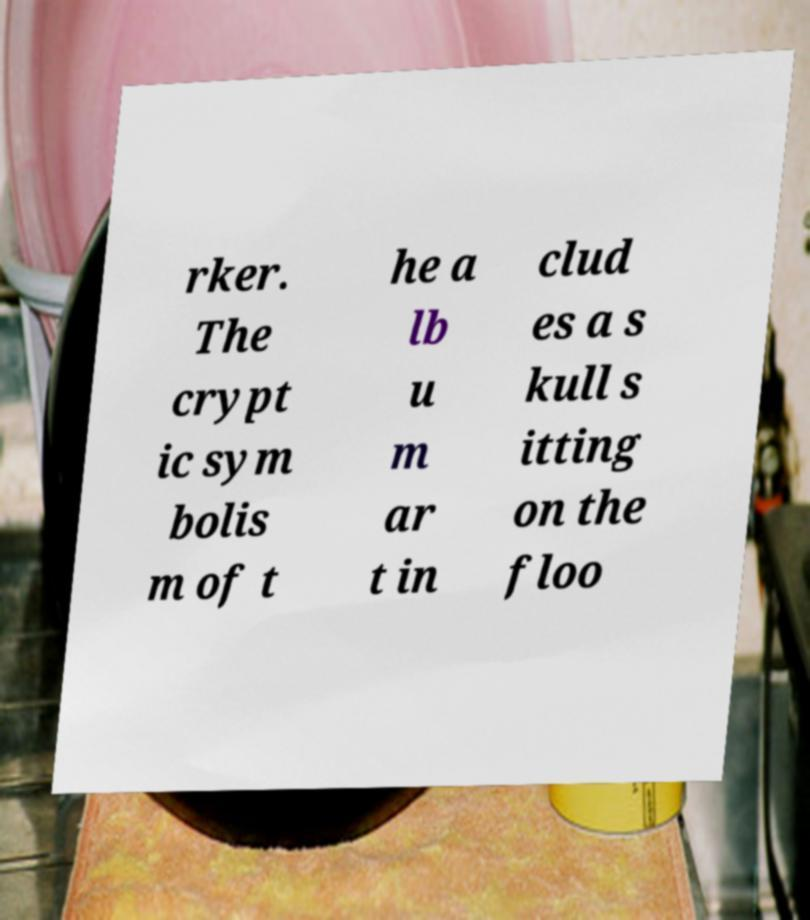I need the written content from this picture converted into text. Can you do that? rker. The crypt ic sym bolis m of t he a lb u m ar t in clud es a s kull s itting on the floo 